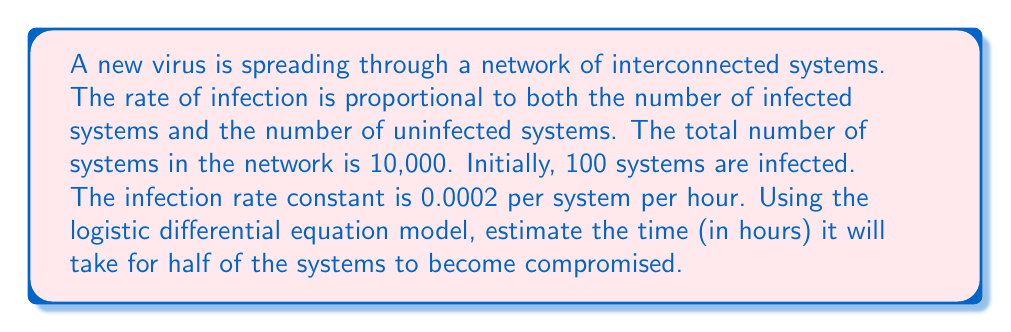Solve this math problem. To solve this problem, we'll use the logistic differential equation model and follow these steps:

1) The logistic differential equation is given by:

   $$\frac{dP}{dt} = kP(N-P)$$

   where $P$ is the number of infected systems, $t$ is time, $k$ is the infection rate constant, and $N$ is the total number of systems.

2) We're given:
   - $N = 10,000$ (total systems)
   - $P_0 = 100$ (initial infected systems)
   - $k = 0.0002$ per system per hour
   - We need to find $t$ when $P = 5,000$ (half of the systems)

3) The solution to the logistic differential equation is:

   $$P(t) = \frac{N}{1 + (\frac{N}{P_0} - 1)e^{-kNt}}$$

4) Substituting our values:

   $$5000 = \frac{10000}{1 + (\frac{10000}{100} - 1)e^{-0.0002 \cdot 10000 \cdot t}}$$

5) Simplify:

   $$1 = \frac{2}{1 + 99e^{-2t}}$$

6) Solve for $t$:
   
   $$1 + 99e^{-2t} = 2$$
   $$99e^{-2t} = 1$$
   $$e^{-2t} = \frac{1}{99}$$
   $$-2t = \ln(\frac{1}{99})$$
   $$t = -\frac{1}{2}\ln(\frac{1}{99}) = \frac{1}{2}\ln(99)$$

7) Calculate the final value:

   $$t = \frac{1}{2} \cdot 4.5951 \approx 2.2976$$

Therefore, it will take approximately 2.30 hours for half of the systems to become compromised.
Answer: 2.30 hours 